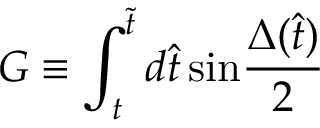<formula> <loc_0><loc_0><loc_500><loc_500>G \equiv \int _ { t } ^ { \tilde { t } } d \hat { t } \, \sin { \frac { \Delta ( \hat { t } ) } { 2 } }</formula> 